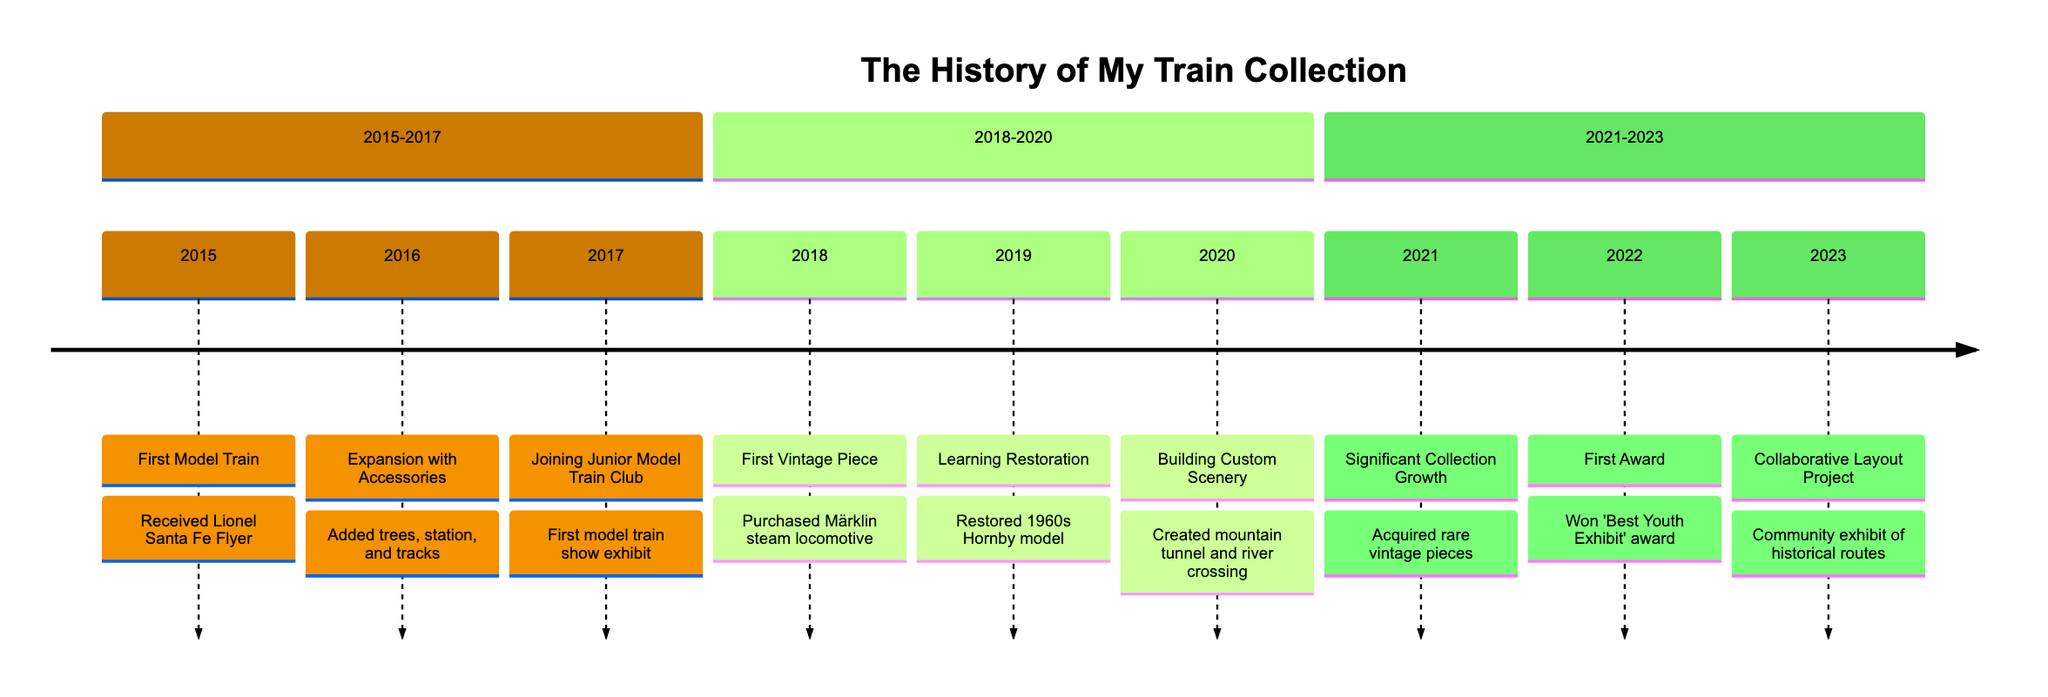What year did I receive my first model train? The diagram shows the event 'First Model Train' occurring in 2015. This is the year I received my first model train set.
Answer: 2015 What event took place in 2022? In 2022, the event shown on the diagram is 'First Award', which notes that I won the 'Best Youth Exhibit' award.
Answer: First Award How many years passed between acquiring my first vintage piece and learning restoration techniques? The first vintage piece was acquired in 2018, and I learned restoration in 2019. This indicates that 1 year passed between these two events.
Answer: 1 year What is the significance of the year 2021 in my train collection history? The year 2021 is significant because it marks 'Significant Collection Growth,’ during which I acquired several rare and vintage pieces.
Answer: Significant Collection Growth What was the first event related to model trains that took place in 2017? The first event in 2017 was 'Joining Junior Model Train Club,' which included my participation in my first model train show exhibit.
Answer: Joining Junior Model Train Club In which year was the mountain tunnel and river crossing scenery created? According to the timeline, the mountain tunnel and river crossing were created in 2020 under the event 'Building Custom Scenery.'
Answer: 2020 Which event highlights collaboration with club members? The timeline indicates that the 'Collaborative Layout Project' in 2023 showcases a joint effort with fellow club members.
Answer: Collaborative Layout Project Between which years did I acquire my first model train and the first vintage piece? The timeline shows that my first model train was received in 2015 and the first vintage piece was acquired in 2018. Therefore, this spans from 2015 to 2018.
Answer: 2015 to 2018 What was the main achievement of the year 2022? The main achievement in 2022 was winning the 'Best Youth Exhibit' award at a regional model train show.
Answer: Best Youth Exhibit 